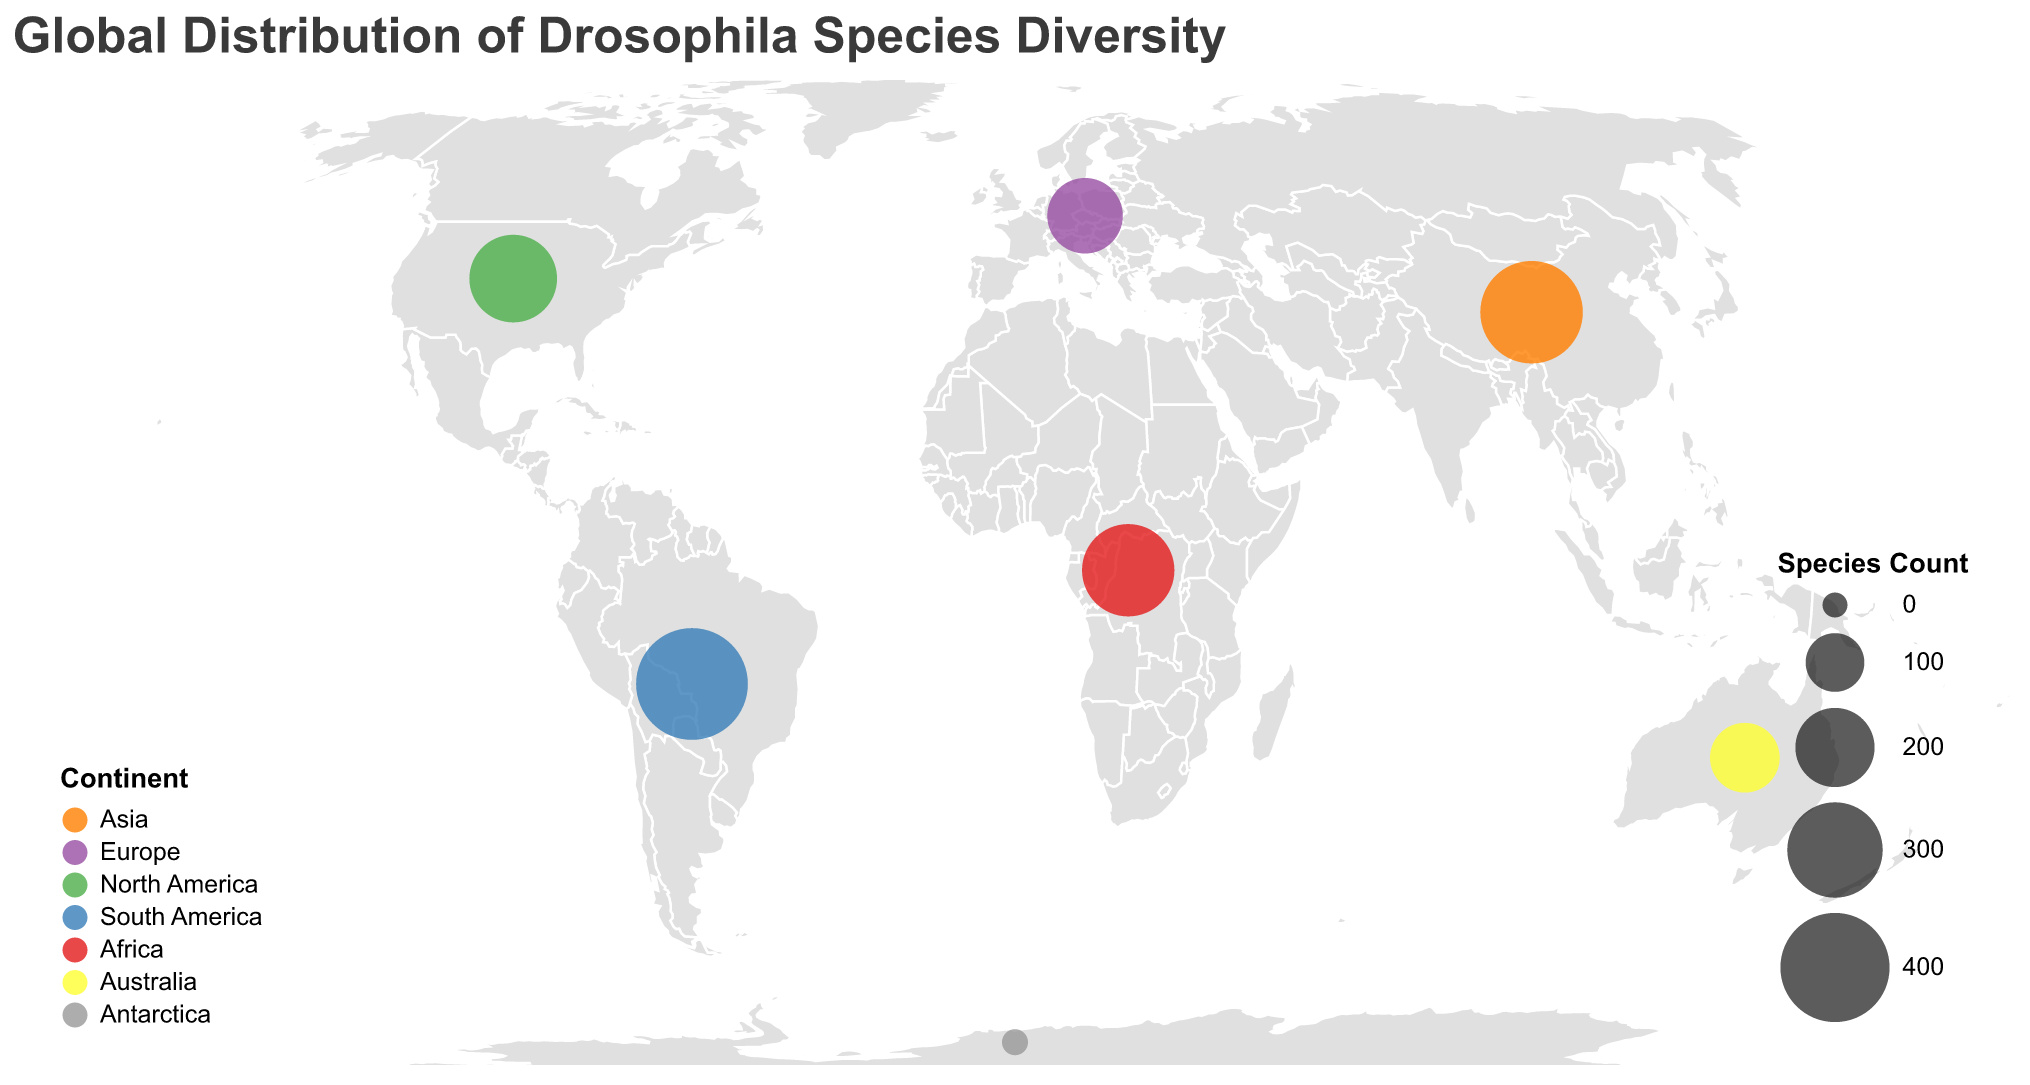Which continent has the highest Drosophila species count? By inspecting the size of circles on the plot, we see that South America has the largest circle. According to the legend, the species count for South America is 420.
Answer: South America Which continent is represented by the yellow color on the plot? Observing the color legend on the bottom left of the plot, the yellow color corresponds to Australia.
Answer: Australia What is the title of the geographic plot? The title is located at the top of the plot. It reads "Global Distribution of Drosophila Species Diversity".
Answer: Global Distribution of Drosophila Species Diversity How many Drosophila species are found in Europe? By looking at the circle on Europe and referring to the tooltip or the data provided, Europe has a species count of 180.
Answer: 180 What is the dominant species of Drosophila in Africa? Looking at the tooltip information for the circle representing Africa, the dominant species is Drosophila yakuba.
Answer: Drosophila yakuba What is the combined species count for Asia and North America? Asia has 350 species, and North America has 250 species. Adding these two gives 350 + 250.
Answer: 600 Which continent has fewer Drosophila species, Australia or Europe? By checking the species count for both continents in the plot, Australia has 150 species and Europe has 180 species. Hence, Australia has fewer species.
Answer: Australia Which specific location has the least Drosophila species diversity? Antarctica has the smallest circle, indicating the least species diversity with only 2 Drosophila species according to the tooltip information.
Answer: Antarctica Compare the Drosophila species count between South America and Africa. Which has more species? South America has 420 species, whereas Africa has 280 species. Therefore, South America has more species.
Answer: South America What is the dominant species in North America, and how many species are there in total? The tooltip on the North America circle indicates the dominant species is Drosophila suzukii and the total species count is 250.
Answer: Drosophila suzukii, 250 